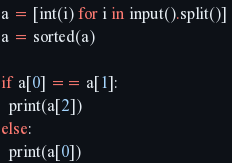Convert code to text. <code><loc_0><loc_0><loc_500><loc_500><_Python_>a = [int(i) for i in input().split()] 
a = sorted(a)

if a[0] == a[1]:
  print(a[2])
else:
  print(a[0])


</code> 